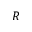<formula> <loc_0><loc_0><loc_500><loc_500>R</formula> 